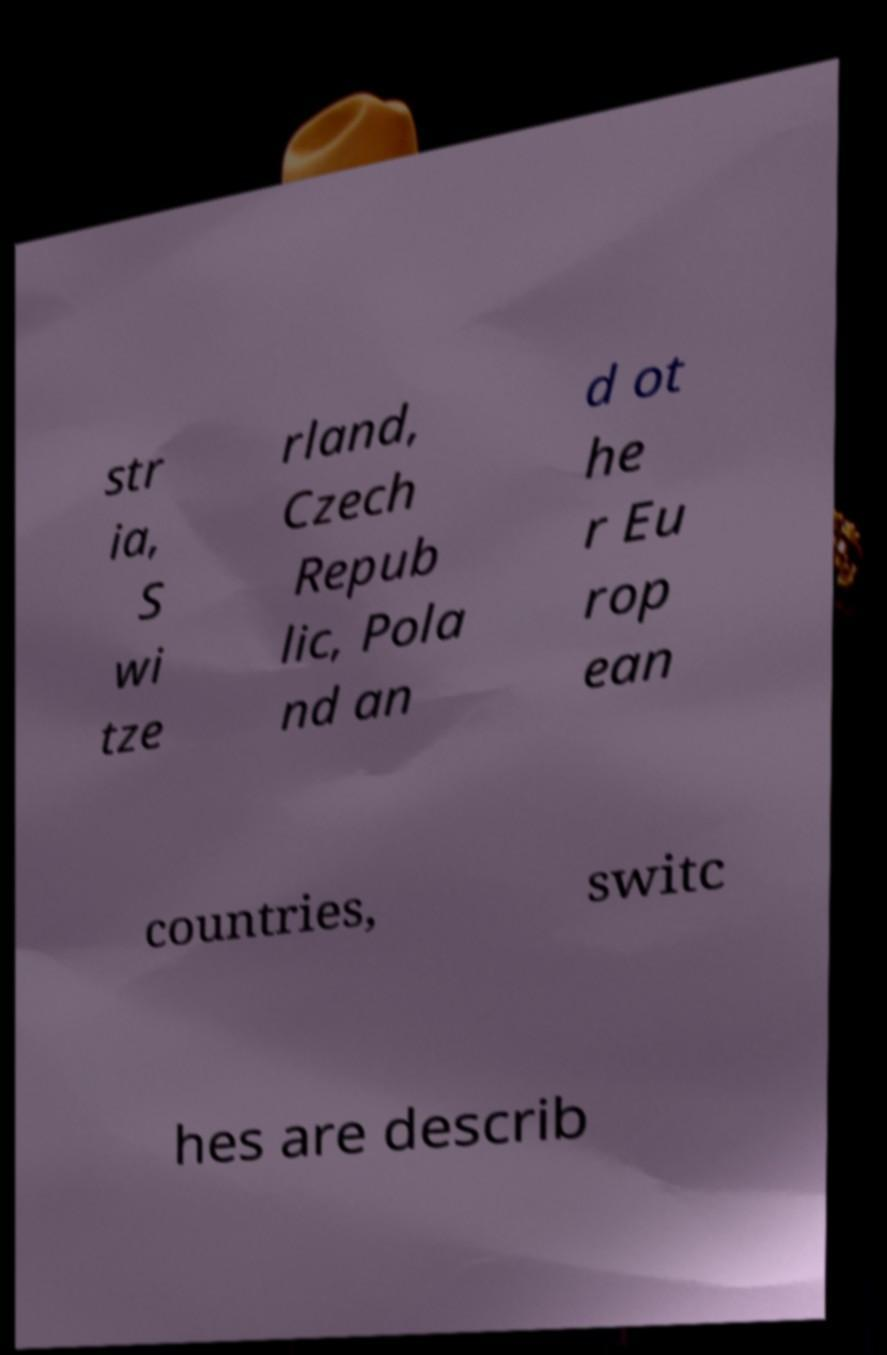I need the written content from this picture converted into text. Can you do that? str ia, S wi tze rland, Czech Repub lic, Pola nd an d ot he r Eu rop ean countries, switc hes are describ 